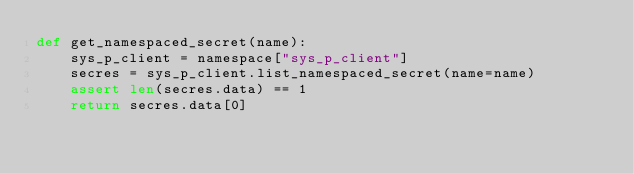Convert code to text. <code><loc_0><loc_0><loc_500><loc_500><_Python_>def get_namespaced_secret(name):
    sys_p_client = namespace["sys_p_client"]
    secres = sys_p_client.list_namespaced_secret(name=name)
    assert len(secres.data) == 1
    return secres.data[0]

</code> 